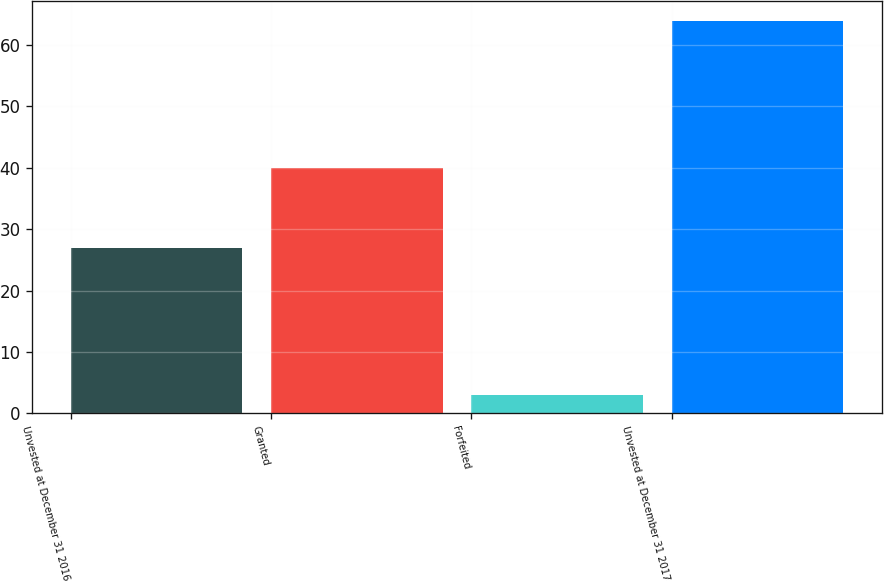Convert chart. <chart><loc_0><loc_0><loc_500><loc_500><bar_chart><fcel>Unvested at December 31 2016<fcel>Granted<fcel>Forfeited<fcel>Unvested at December 31 2017<nl><fcel>27<fcel>40<fcel>3<fcel>64<nl></chart> 